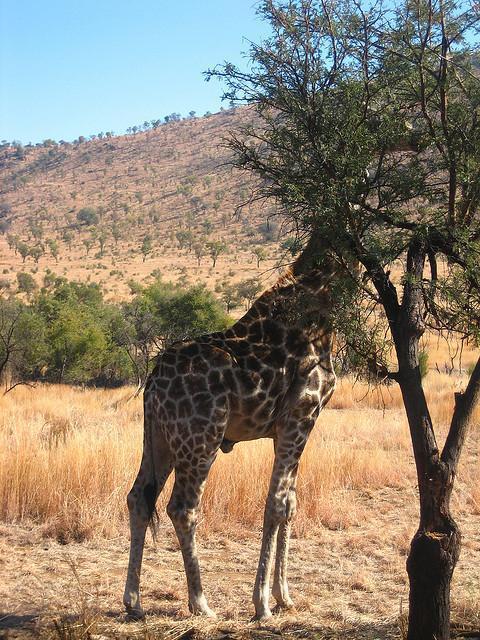How many red cars transporting bicycles to the left are there? there are red cars to the right transporting bicycles too?
Give a very brief answer. 0. 